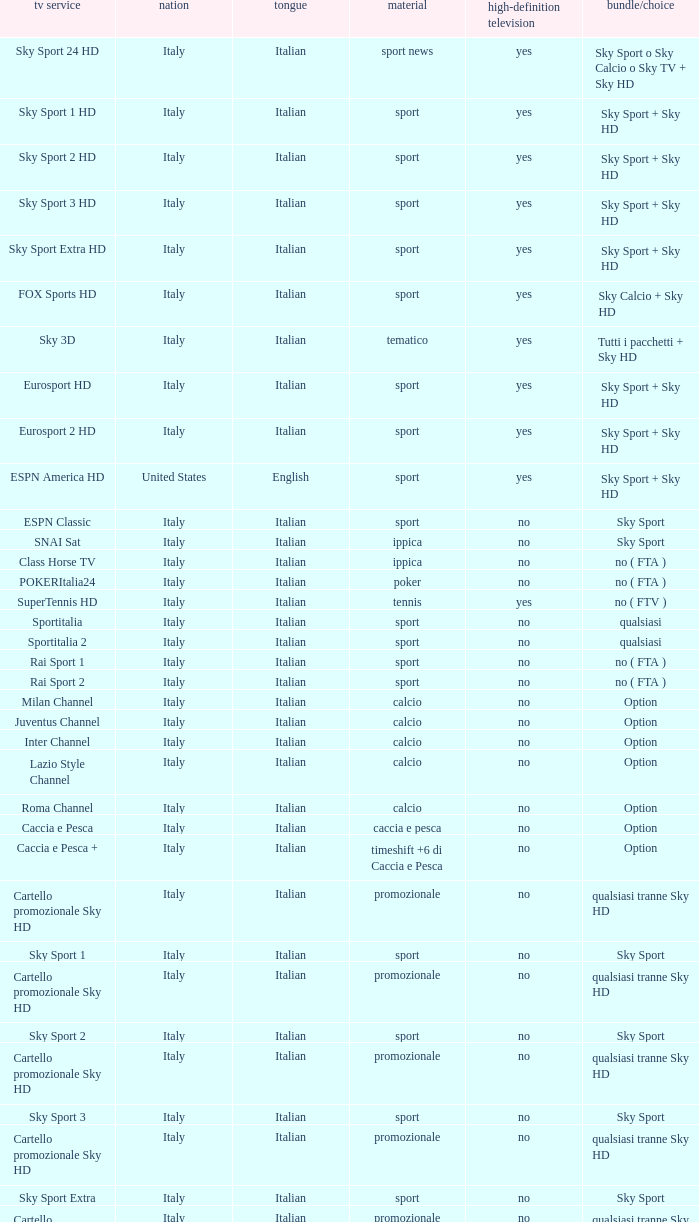What is Television Service, when Content is Calcio, and when Package/Option is Option? Milan Channel, Juventus Channel, Inter Channel, Lazio Style Channel, Roma Channel. Could you help me parse every detail presented in this table? {'header': ['tv service', 'nation', 'tongue', 'material', 'high-definition television', 'bundle/choice'], 'rows': [['Sky Sport 24 HD', 'Italy', 'Italian', 'sport news', 'yes', 'Sky Sport o Sky Calcio o Sky TV + Sky HD'], ['Sky Sport 1 HD', 'Italy', 'Italian', 'sport', 'yes', 'Sky Sport + Sky HD'], ['Sky Sport 2 HD', 'Italy', 'Italian', 'sport', 'yes', 'Sky Sport + Sky HD'], ['Sky Sport 3 HD', 'Italy', 'Italian', 'sport', 'yes', 'Sky Sport + Sky HD'], ['Sky Sport Extra HD', 'Italy', 'Italian', 'sport', 'yes', 'Sky Sport + Sky HD'], ['FOX Sports HD', 'Italy', 'Italian', 'sport', 'yes', 'Sky Calcio + Sky HD'], ['Sky 3D', 'Italy', 'Italian', 'tematico', 'yes', 'Tutti i pacchetti + Sky HD'], ['Eurosport HD', 'Italy', 'Italian', 'sport', 'yes', 'Sky Sport + Sky HD'], ['Eurosport 2 HD', 'Italy', 'Italian', 'sport', 'yes', 'Sky Sport + Sky HD'], ['ESPN America HD', 'United States', 'English', 'sport', 'yes', 'Sky Sport + Sky HD'], ['ESPN Classic', 'Italy', 'Italian', 'sport', 'no', 'Sky Sport'], ['SNAI Sat', 'Italy', 'Italian', 'ippica', 'no', 'Sky Sport'], ['Class Horse TV', 'Italy', 'Italian', 'ippica', 'no', 'no ( FTA )'], ['POKERItalia24', 'Italy', 'Italian', 'poker', 'no', 'no ( FTA )'], ['SuperTennis HD', 'Italy', 'Italian', 'tennis', 'yes', 'no ( FTV )'], ['Sportitalia', 'Italy', 'Italian', 'sport', 'no', 'qualsiasi'], ['Sportitalia 2', 'Italy', 'Italian', 'sport', 'no', 'qualsiasi'], ['Rai Sport 1', 'Italy', 'Italian', 'sport', 'no', 'no ( FTA )'], ['Rai Sport 2', 'Italy', 'Italian', 'sport', 'no', 'no ( FTA )'], ['Milan Channel', 'Italy', 'Italian', 'calcio', 'no', 'Option'], ['Juventus Channel', 'Italy', 'Italian', 'calcio', 'no', 'Option'], ['Inter Channel', 'Italy', 'Italian', 'calcio', 'no', 'Option'], ['Lazio Style Channel', 'Italy', 'Italian', 'calcio', 'no', 'Option'], ['Roma Channel', 'Italy', 'Italian', 'calcio', 'no', 'Option'], ['Caccia e Pesca', 'Italy', 'Italian', 'caccia e pesca', 'no', 'Option'], ['Caccia e Pesca +', 'Italy', 'Italian', 'timeshift +6 di Caccia e Pesca', 'no', 'Option'], ['Cartello promozionale Sky HD', 'Italy', 'Italian', 'promozionale', 'no', 'qualsiasi tranne Sky HD'], ['Sky Sport 1', 'Italy', 'Italian', 'sport', 'no', 'Sky Sport'], ['Cartello promozionale Sky HD', 'Italy', 'Italian', 'promozionale', 'no', 'qualsiasi tranne Sky HD'], ['Sky Sport 2', 'Italy', 'Italian', 'sport', 'no', 'Sky Sport'], ['Cartello promozionale Sky HD', 'Italy', 'Italian', 'promozionale', 'no', 'qualsiasi tranne Sky HD'], ['Sky Sport 3', 'Italy', 'Italian', 'sport', 'no', 'Sky Sport'], ['Cartello promozionale Sky HD', 'Italy', 'Italian', 'promozionale', 'no', 'qualsiasi tranne Sky HD'], ['Sky Sport Extra', 'Italy', 'Italian', 'sport', 'no', 'Sky Sport'], ['Cartello promozionale Sky HD', 'Italy', 'Italian', 'promozionale', 'no', 'qualsiasi tranne Sky HD'], ['Sky Supercalcio', 'Italy', 'Italian', 'calcio', 'no', 'Sky Calcio'], ['Cartello promozionale Sky HD', 'Italy', 'Italian', 'promozionale', 'no', 'qualsiasi tranne Sky HD'], ['Eurosport', 'Italy', 'Italian', 'sport', 'no', 'Sky Sport'], ['Eurosport 2', 'Italy', 'Italian', 'sport', 'no', 'Sky Sport'], ['ESPN America', 'Italy', 'Italian', 'sport', 'no', 'Sky Sport']]} 